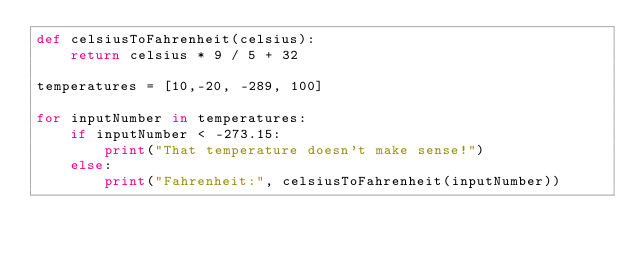<code> <loc_0><loc_0><loc_500><loc_500><_Python_>def celsiusToFahrenheit(celsius):
    return celsius * 9 / 5 + 32

temperatures = [10,-20, -289, 100]

for inputNumber in temperatures:
    if inputNumber < -273.15:
        print("That temperature doesn't make sense!")
    else:
        print("Fahrenheit:", celsiusToFahrenheit(inputNumber))
</code> 